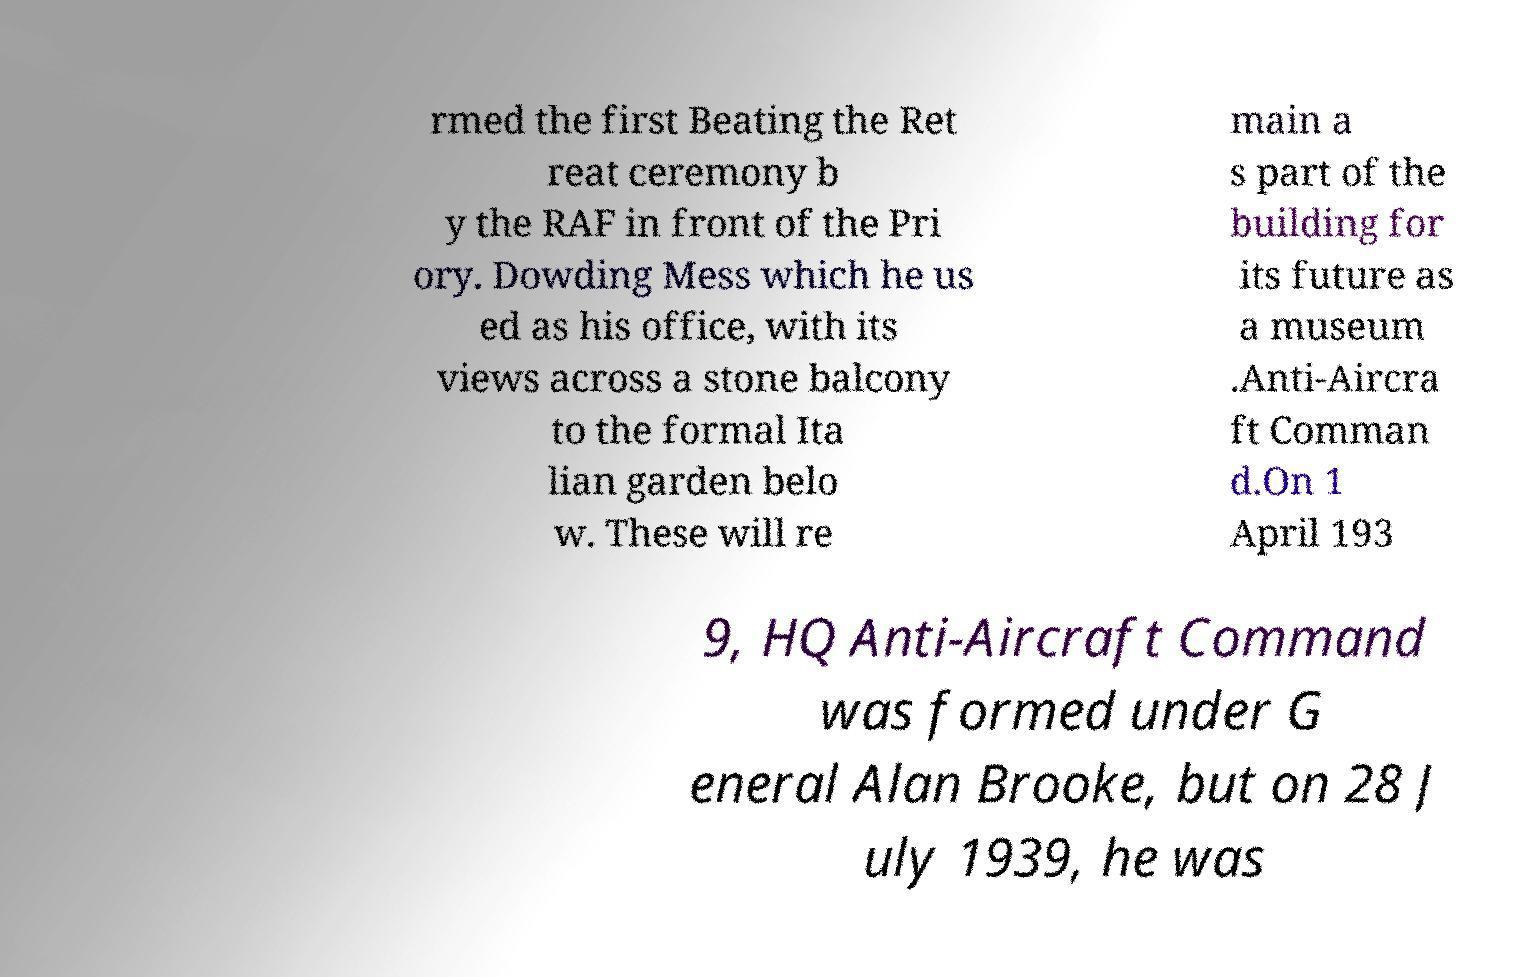For documentation purposes, I need the text within this image transcribed. Could you provide that? rmed the first Beating the Ret reat ceremony b y the RAF in front of the Pri ory. Dowding Mess which he us ed as his office, with its views across a stone balcony to the formal Ita lian garden belo w. These will re main a s part of the building for its future as a museum .Anti-Aircra ft Comman d.On 1 April 193 9, HQ Anti-Aircraft Command was formed under G eneral Alan Brooke, but on 28 J uly 1939, he was 